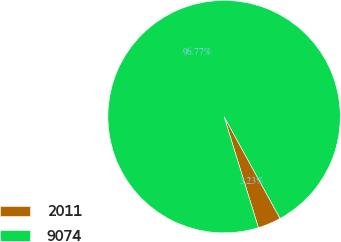Convert chart to OTSL. <chart><loc_0><loc_0><loc_500><loc_500><pie_chart><fcel>2011<fcel>9074<nl><fcel>3.23%<fcel>96.77%<nl></chart> 